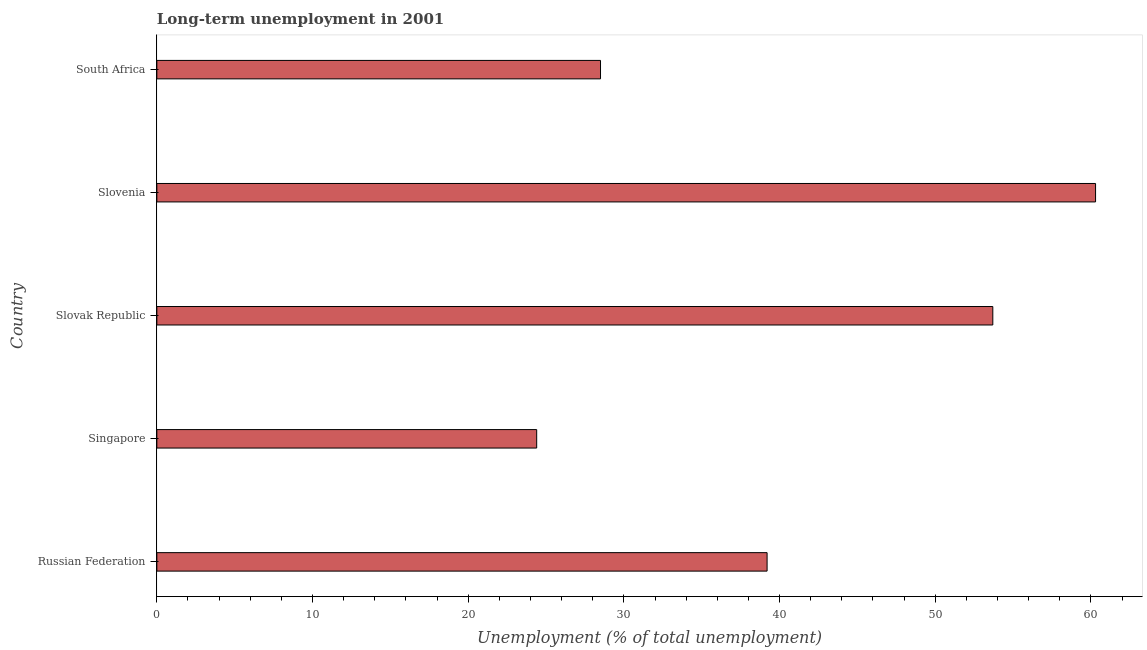Does the graph contain any zero values?
Your answer should be compact. No. What is the title of the graph?
Keep it short and to the point. Long-term unemployment in 2001. What is the label or title of the X-axis?
Provide a short and direct response. Unemployment (% of total unemployment). What is the long-term unemployment in Singapore?
Provide a short and direct response. 24.4. Across all countries, what is the maximum long-term unemployment?
Keep it short and to the point. 60.3. Across all countries, what is the minimum long-term unemployment?
Your answer should be compact. 24.4. In which country was the long-term unemployment maximum?
Your answer should be compact. Slovenia. In which country was the long-term unemployment minimum?
Provide a succinct answer. Singapore. What is the sum of the long-term unemployment?
Ensure brevity in your answer.  206.1. What is the average long-term unemployment per country?
Make the answer very short. 41.22. What is the median long-term unemployment?
Provide a short and direct response. 39.2. What is the ratio of the long-term unemployment in Singapore to that in Slovenia?
Offer a very short reply. 0.41. Is the long-term unemployment in Slovak Republic less than that in South Africa?
Keep it short and to the point. No. Is the sum of the long-term unemployment in Singapore and South Africa greater than the maximum long-term unemployment across all countries?
Make the answer very short. No. What is the difference between the highest and the lowest long-term unemployment?
Provide a succinct answer. 35.9. How many bars are there?
Your response must be concise. 5. Are all the bars in the graph horizontal?
Ensure brevity in your answer.  Yes. How many countries are there in the graph?
Your answer should be very brief. 5. What is the difference between two consecutive major ticks on the X-axis?
Your answer should be compact. 10. What is the Unemployment (% of total unemployment) of Russian Federation?
Offer a very short reply. 39.2. What is the Unemployment (% of total unemployment) of Singapore?
Ensure brevity in your answer.  24.4. What is the Unemployment (% of total unemployment) in Slovak Republic?
Your answer should be compact. 53.7. What is the Unemployment (% of total unemployment) in Slovenia?
Give a very brief answer. 60.3. What is the difference between the Unemployment (% of total unemployment) in Russian Federation and Singapore?
Offer a terse response. 14.8. What is the difference between the Unemployment (% of total unemployment) in Russian Federation and Slovak Republic?
Provide a succinct answer. -14.5. What is the difference between the Unemployment (% of total unemployment) in Russian Federation and Slovenia?
Provide a short and direct response. -21.1. What is the difference between the Unemployment (% of total unemployment) in Russian Federation and South Africa?
Provide a short and direct response. 10.7. What is the difference between the Unemployment (% of total unemployment) in Singapore and Slovak Republic?
Ensure brevity in your answer.  -29.3. What is the difference between the Unemployment (% of total unemployment) in Singapore and Slovenia?
Offer a terse response. -35.9. What is the difference between the Unemployment (% of total unemployment) in Singapore and South Africa?
Your answer should be compact. -4.1. What is the difference between the Unemployment (% of total unemployment) in Slovak Republic and South Africa?
Give a very brief answer. 25.2. What is the difference between the Unemployment (% of total unemployment) in Slovenia and South Africa?
Ensure brevity in your answer.  31.8. What is the ratio of the Unemployment (% of total unemployment) in Russian Federation to that in Singapore?
Give a very brief answer. 1.61. What is the ratio of the Unemployment (% of total unemployment) in Russian Federation to that in Slovak Republic?
Keep it short and to the point. 0.73. What is the ratio of the Unemployment (% of total unemployment) in Russian Federation to that in Slovenia?
Keep it short and to the point. 0.65. What is the ratio of the Unemployment (% of total unemployment) in Russian Federation to that in South Africa?
Your answer should be compact. 1.38. What is the ratio of the Unemployment (% of total unemployment) in Singapore to that in Slovak Republic?
Provide a short and direct response. 0.45. What is the ratio of the Unemployment (% of total unemployment) in Singapore to that in Slovenia?
Provide a short and direct response. 0.41. What is the ratio of the Unemployment (% of total unemployment) in Singapore to that in South Africa?
Offer a terse response. 0.86. What is the ratio of the Unemployment (% of total unemployment) in Slovak Republic to that in Slovenia?
Your answer should be very brief. 0.89. What is the ratio of the Unemployment (% of total unemployment) in Slovak Republic to that in South Africa?
Your answer should be very brief. 1.88. What is the ratio of the Unemployment (% of total unemployment) in Slovenia to that in South Africa?
Give a very brief answer. 2.12. 